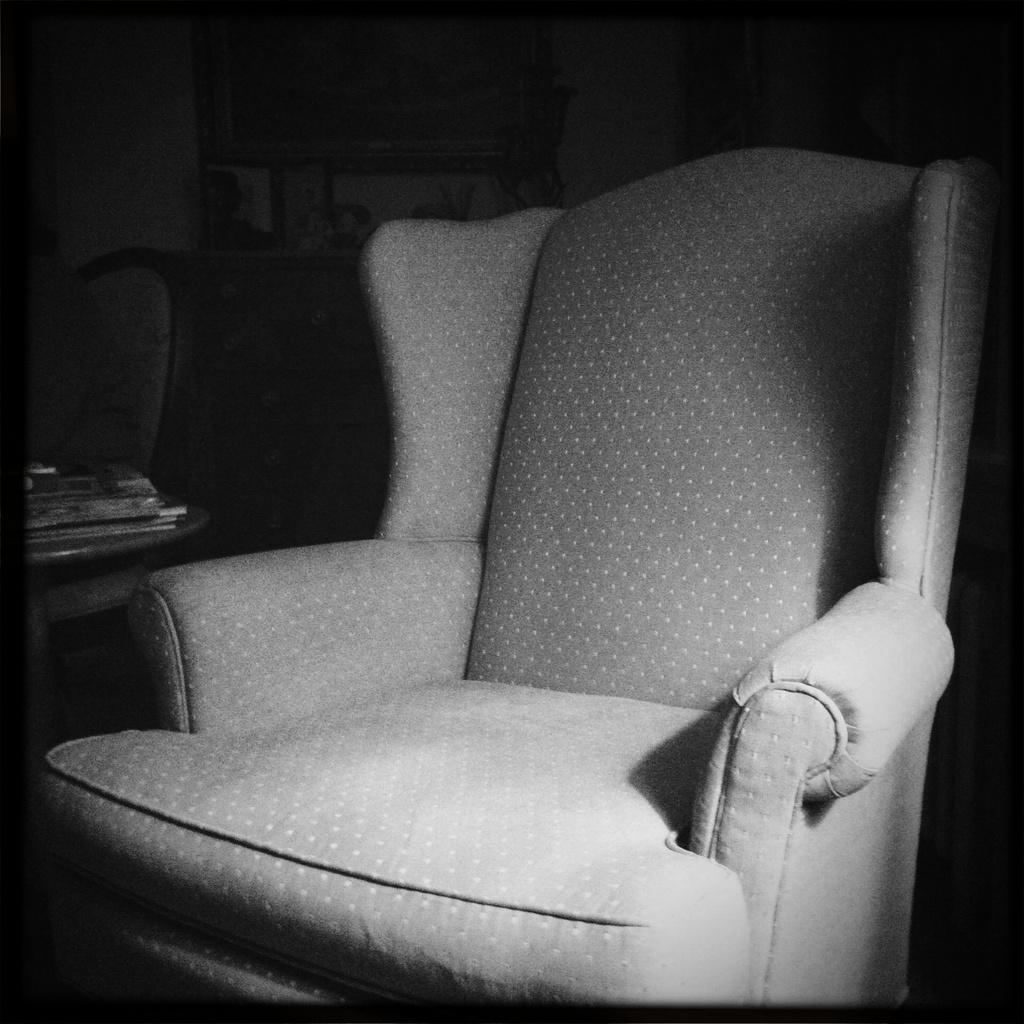Can you describe this image briefly? This is a black and white picture. In this there is a chair. In the back there is a chair with books. 